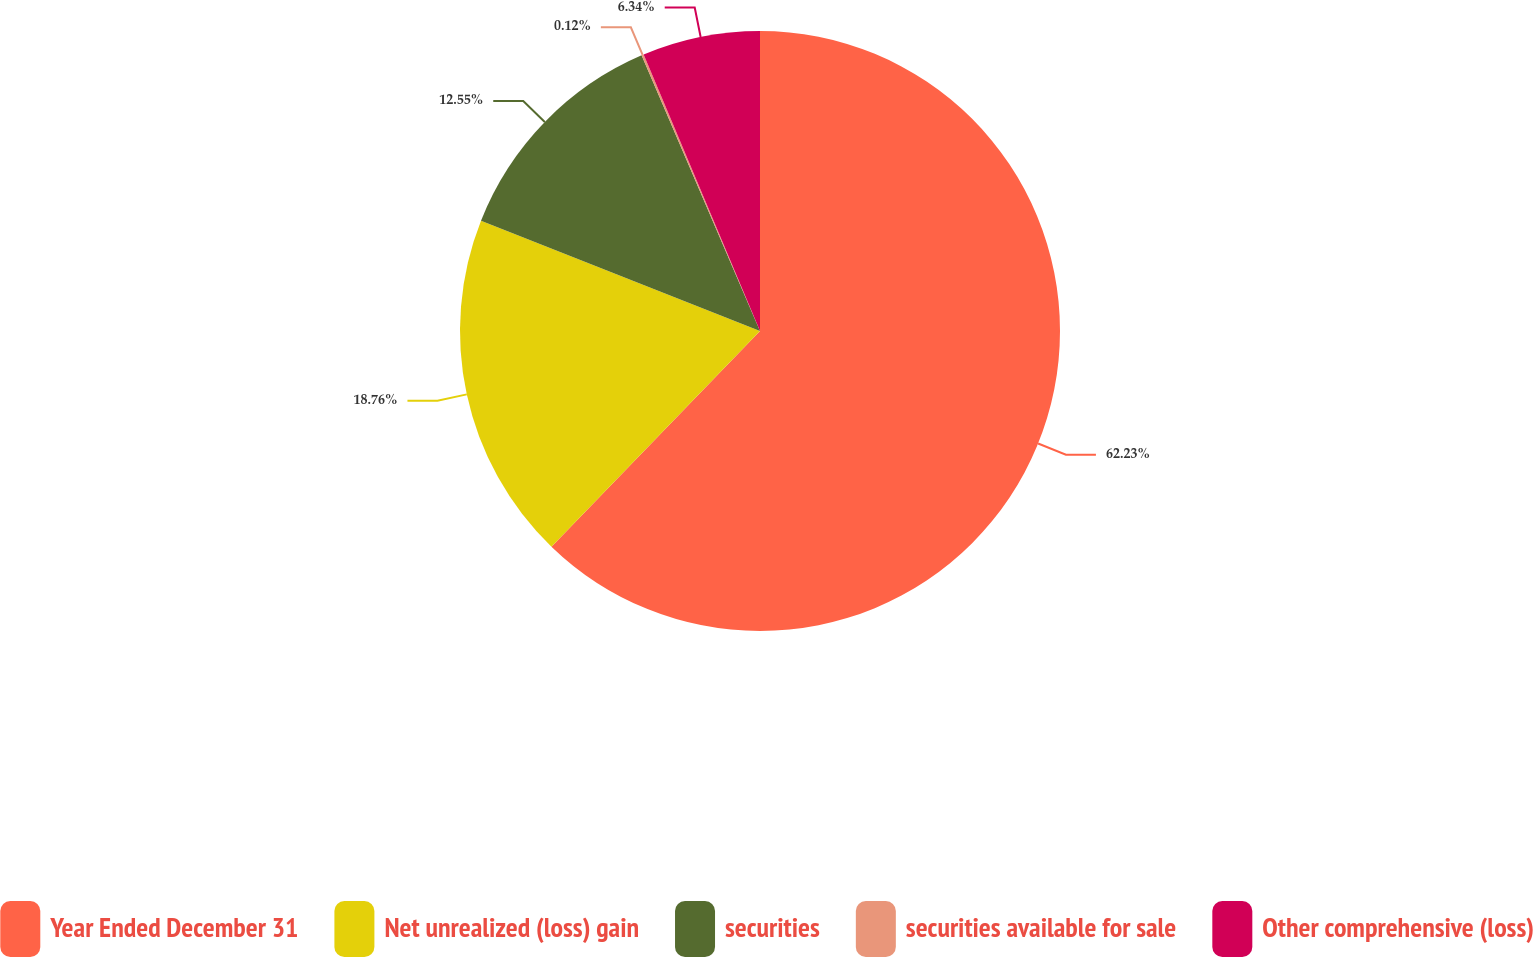Convert chart to OTSL. <chart><loc_0><loc_0><loc_500><loc_500><pie_chart><fcel>Year Ended December 31<fcel>Net unrealized (loss) gain<fcel>securities<fcel>securities available for sale<fcel>Other comprehensive (loss)<nl><fcel>62.24%<fcel>18.76%<fcel>12.55%<fcel>0.12%<fcel>6.34%<nl></chart> 